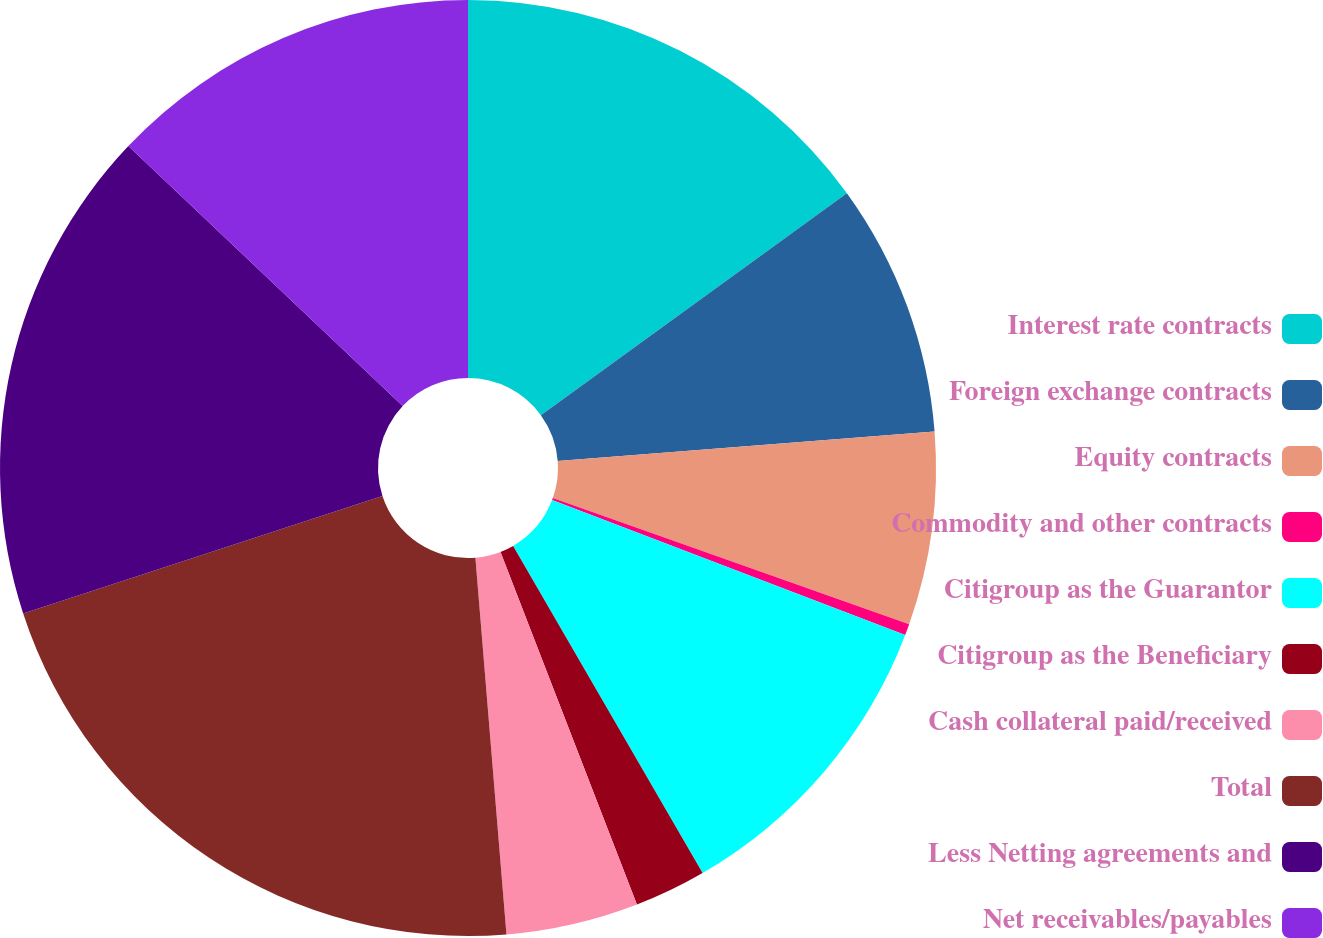Convert chart to OTSL. <chart><loc_0><loc_0><loc_500><loc_500><pie_chart><fcel>Interest rate contracts<fcel>Foreign exchange contracts<fcel>Equity contracts<fcel>Commodity and other contracts<fcel>Citigroup as the Guarantor<fcel>Citigroup as the Beneficiary<fcel>Cash collateral paid/received<fcel>Total<fcel>Less Netting agreements and<fcel>Net receivables/payables<nl><fcel>15.02%<fcel>8.75%<fcel>6.66%<fcel>0.39%<fcel>10.84%<fcel>2.48%<fcel>4.57%<fcel>21.29%<fcel>17.11%<fcel>12.93%<nl></chart> 